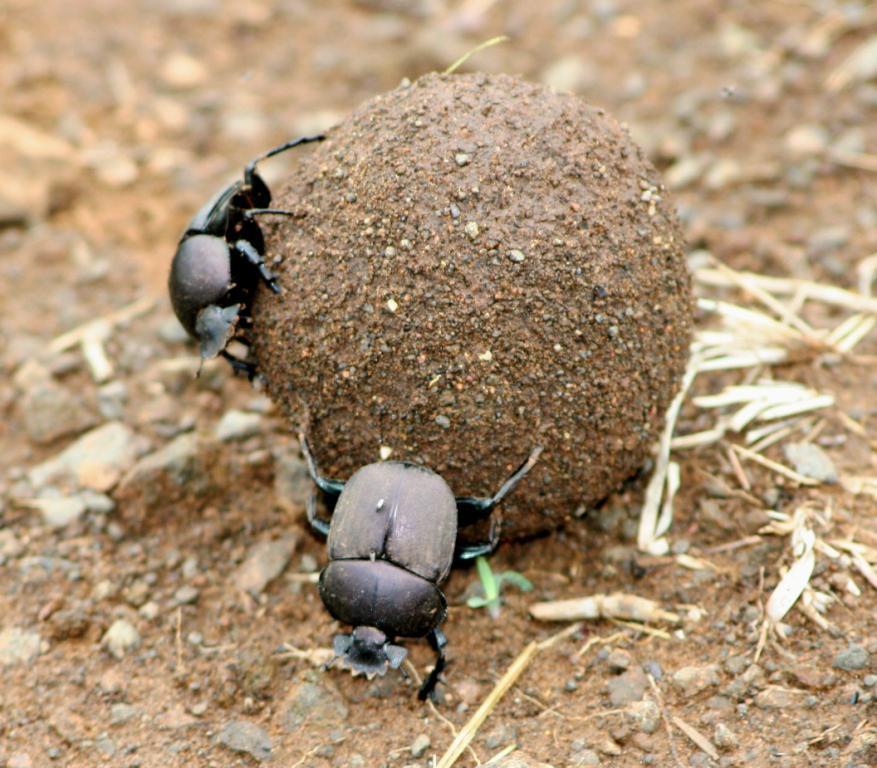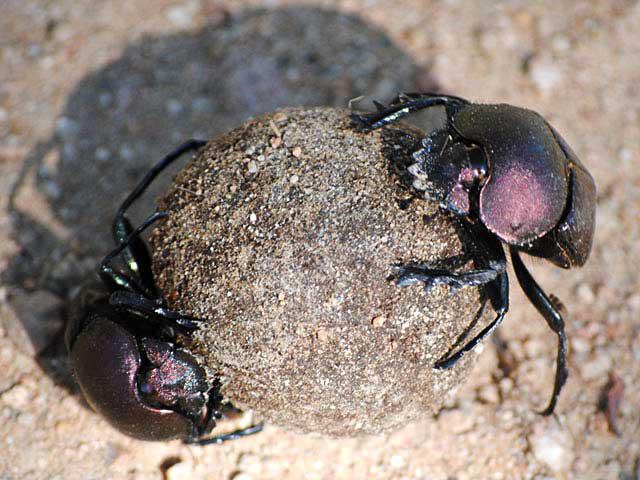The first image is the image on the left, the second image is the image on the right. Examine the images to the left and right. Is the description "The right image has two beetles pushing a dung ball." accurate? Answer yes or no. Yes. The first image is the image on the left, the second image is the image on the right. For the images shown, is this caption "In each image, there are two beetles holding a dungball.›" true? Answer yes or no. Yes. 